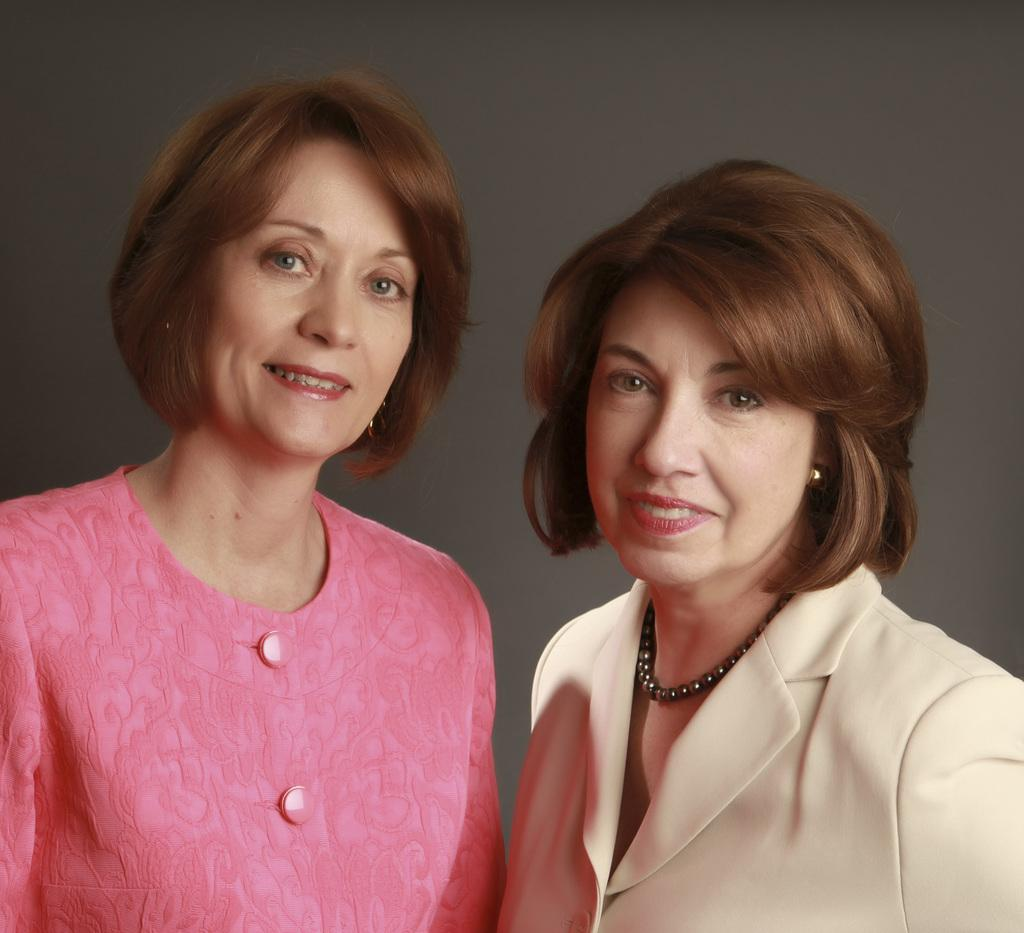How many women are present in the image? There are two women in the image. What expressions do the women have? Both women are smiling. Can you describe the clothing of the woman on the right side? The woman on the right side is wearing a suit. What color is the dress worn by the other woman? The other woman is wearing a pink color dress. Are there any letters visible in the image? There are no letters present in the image. Can you see any flames in the image? There are no flames present in the image. 